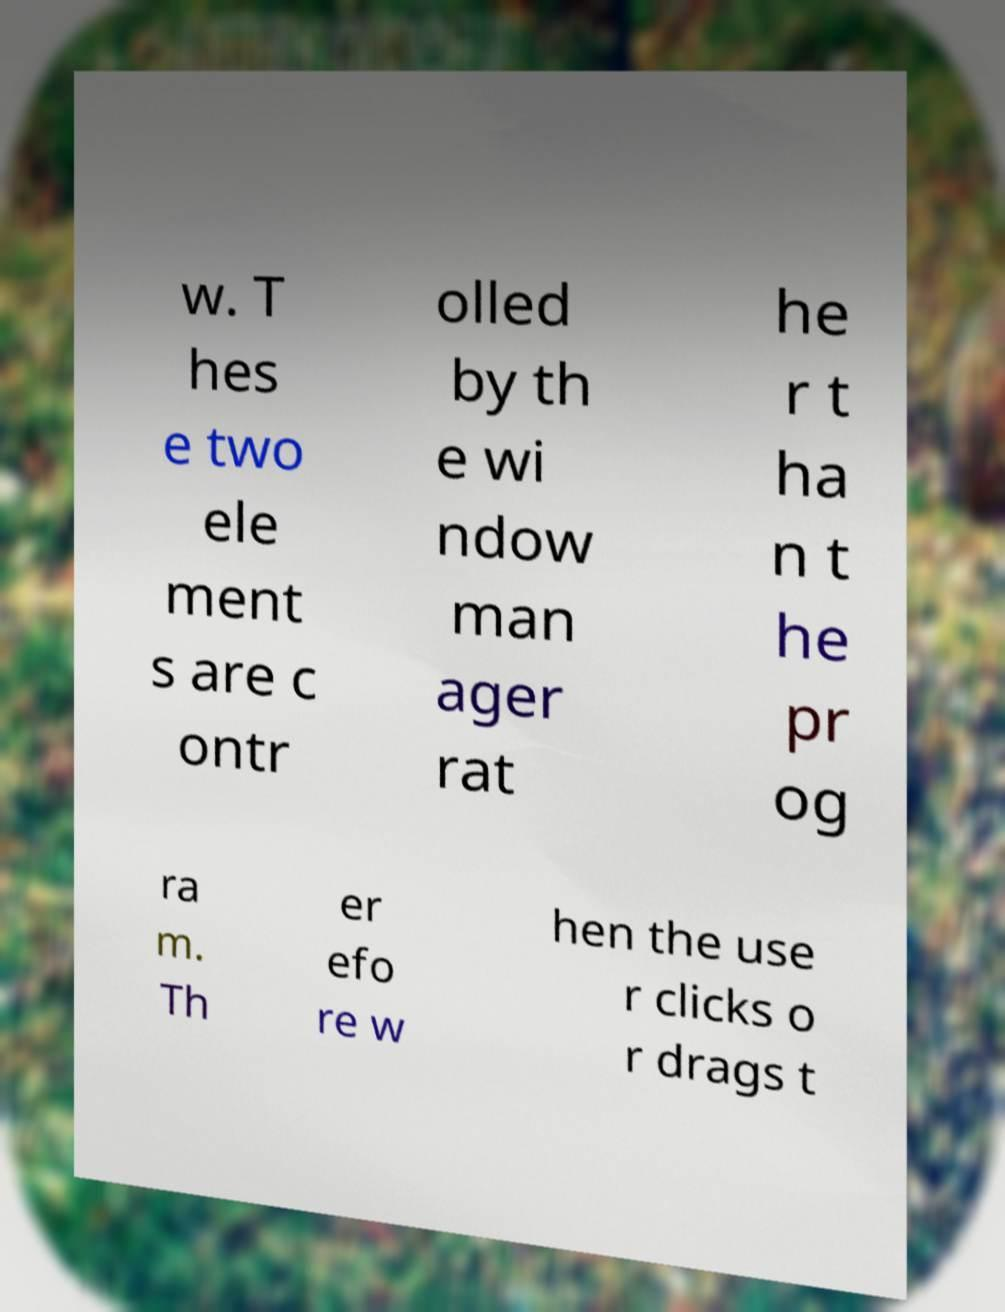Could you extract and type out the text from this image? w. T hes e two ele ment s are c ontr olled by th e wi ndow man ager rat he r t ha n t he pr og ra m. Th er efo re w hen the use r clicks o r drags t 